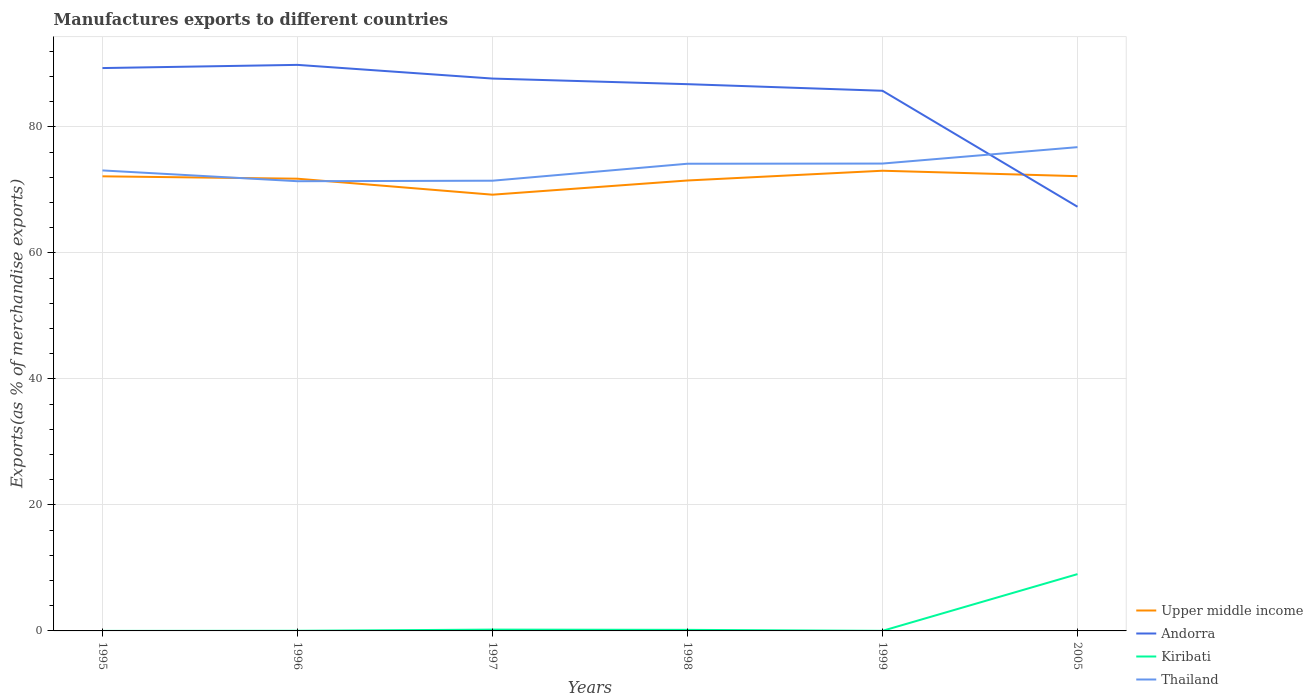Is the number of lines equal to the number of legend labels?
Your response must be concise. Yes. Across all years, what is the maximum percentage of exports to different countries in Thailand?
Keep it short and to the point. 71.39. In which year was the percentage of exports to different countries in Andorra maximum?
Your answer should be very brief. 2005. What is the total percentage of exports to different countries in Upper middle income in the graph?
Keep it short and to the point. -2.94. What is the difference between the highest and the second highest percentage of exports to different countries in Andorra?
Give a very brief answer. 22.52. How many lines are there?
Give a very brief answer. 4. What is the difference between two consecutive major ticks on the Y-axis?
Ensure brevity in your answer.  20. Are the values on the major ticks of Y-axis written in scientific E-notation?
Your response must be concise. No. Where does the legend appear in the graph?
Make the answer very short. Bottom right. How many legend labels are there?
Provide a succinct answer. 4. What is the title of the graph?
Offer a very short reply. Manufactures exports to different countries. Does "St. Lucia" appear as one of the legend labels in the graph?
Ensure brevity in your answer.  No. What is the label or title of the Y-axis?
Provide a short and direct response. Exports(as % of merchandise exports). What is the Exports(as % of merchandise exports) of Upper middle income in 1995?
Give a very brief answer. 72.16. What is the Exports(as % of merchandise exports) in Andorra in 1995?
Your answer should be very brief. 89.35. What is the Exports(as % of merchandise exports) of Kiribati in 1995?
Your answer should be compact. 0. What is the Exports(as % of merchandise exports) of Thailand in 1995?
Make the answer very short. 73.1. What is the Exports(as % of merchandise exports) in Upper middle income in 1996?
Provide a short and direct response. 71.79. What is the Exports(as % of merchandise exports) of Andorra in 1996?
Make the answer very short. 89.86. What is the Exports(as % of merchandise exports) in Kiribati in 1996?
Provide a succinct answer. 0.02. What is the Exports(as % of merchandise exports) in Thailand in 1996?
Make the answer very short. 71.39. What is the Exports(as % of merchandise exports) of Upper middle income in 1997?
Your answer should be very brief. 69.25. What is the Exports(as % of merchandise exports) in Andorra in 1997?
Ensure brevity in your answer.  87.68. What is the Exports(as % of merchandise exports) in Kiribati in 1997?
Give a very brief answer. 0.21. What is the Exports(as % of merchandise exports) of Thailand in 1997?
Provide a succinct answer. 71.47. What is the Exports(as % of merchandise exports) of Upper middle income in 1998?
Offer a terse response. 71.5. What is the Exports(as % of merchandise exports) in Andorra in 1998?
Keep it short and to the point. 86.79. What is the Exports(as % of merchandise exports) in Kiribati in 1998?
Your answer should be compact. 0.17. What is the Exports(as % of merchandise exports) in Thailand in 1998?
Keep it short and to the point. 74.16. What is the Exports(as % of merchandise exports) of Upper middle income in 1999?
Provide a succinct answer. 73.05. What is the Exports(as % of merchandise exports) of Andorra in 1999?
Give a very brief answer. 85.75. What is the Exports(as % of merchandise exports) of Kiribati in 1999?
Your answer should be very brief. 0.01. What is the Exports(as % of merchandise exports) of Thailand in 1999?
Your answer should be very brief. 74.19. What is the Exports(as % of merchandise exports) of Upper middle income in 2005?
Your answer should be compact. 72.19. What is the Exports(as % of merchandise exports) of Andorra in 2005?
Offer a terse response. 67.34. What is the Exports(as % of merchandise exports) of Kiribati in 2005?
Keep it short and to the point. 9.02. What is the Exports(as % of merchandise exports) of Thailand in 2005?
Offer a terse response. 76.8. Across all years, what is the maximum Exports(as % of merchandise exports) of Upper middle income?
Your answer should be very brief. 73.05. Across all years, what is the maximum Exports(as % of merchandise exports) of Andorra?
Your answer should be compact. 89.86. Across all years, what is the maximum Exports(as % of merchandise exports) of Kiribati?
Make the answer very short. 9.02. Across all years, what is the maximum Exports(as % of merchandise exports) of Thailand?
Provide a short and direct response. 76.8. Across all years, what is the minimum Exports(as % of merchandise exports) in Upper middle income?
Your response must be concise. 69.25. Across all years, what is the minimum Exports(as % of merchandise exports) in Andorra?
Your answer should be compact. 67.34. Across all years, what is the minimum Exports(as % of merchandise exports) of Kiribati?
Ensure brevity in your answer.  0. Across all years, what is the minimum Exports(as % of merchandise exports) of Thailand?
Provide a short and direct response. 71.39. What is the total Exports(as % of merchandise exports) in Upper middle income in the graph?
Offer a very short reply. 429.95. What is the total Exports(as % of merchandise exports) in Andorra in the graph?
Offer a very short reply. 506.76. What is the total Exports(as % of merchandise exports) in Kiribati in the graph?
Keep it short and to the point. 9.43. What is the total Exports(as % of merchandise exports) of Thailand in the graph?
Keep it short and to the point. 441.11. What is the difference between the Exports(as % of merchandise exports) of Upper middle income in 1995 and that in 1996?
Provide a short and direct response. 0.38. What is the difference between the Exports(as % of merchandise exports) in Andorra in 1995 and that in 1996?
Offer a terse response. -0.51. What is the difference between the Exports(as % of merchandise exports) in Kiribati in 1995 and that in 1996?
Offer a very short reply. -0.02. What is the difference between the Exports(as % of merchandise exports) in Thailand in 1995 and that in 1996?
Provide a succinct answer. 1.71. What is the difference between the Exports(as % of merchandise exports) in Upper middle income in 1995 and that in 1997?
Keep it short and to the point. 2.92. What is the difference between the Exports(as % of merchandise exports) of Andorra in 1995 and that in 1997?
Provide a short and direct response. 1.67. What is the difference between the Exports(as % of merchandise exports) in Kiribati in 1995 and that in 1997?
Keep it short and to the point. -0.21. What is the difference between the Exports(as % of merchandise exports) of Thailand in 1995 and that in 1997?
Provide a succinct answer. 1.63. What is the difference between the Exports(as % of merchandise exports) of Upper middle income in 1995 and that in 1998?
Make the answer very short. 0.66. What is the difference between the Exports(as % of merchandise exports) of Andorra in 1995 and that in 1998?
Give a very brief answer. 2.56. What is the difference between the Exports(as % of merchandise exports) in Kiribati in 1995 and that in 1998?
Make the answer very short. -0.17. What is the difference between the Exports(as % of merchandise exports) in Thailand in 1995 and that in 1998?
Keep it short and to the point. -1.06. What is the difference between the Exports(as % of merchandise exports) in Upper middle income in 1995 and that in 1999?
Make the answer very short. -0.89. What is the difference between the Exports(as % of merchandise exports) in Andorra in 1995 and that in 1999?
Give a very brief answer. 3.6. What is the difference between the Exports(as % of merchandise exports) in Kiribati in 1995 and that in 1999?
Provide a succinct answer. -0.01. What is the difference between the Exports(as % of merchandise exports) of Thailand in 1995 and that in 1999?
Give a very brief answer. -1.09. What is the difference between the Exports(as % of merchandise exports) of Upper middle income in 1995 and that in 2005?
Offer a very short reply. -0.03. What is the difference between the Exports(as % of merchandise exports) of Andorra in 1995 and that in 2005?
Give a very brief answer. 22.01. What is the difference between the Exports(as % of merchandise exports) of Kiribati in 1995 and that in 2005?
Offer a very short reply. -9.02. What is the difference between the Exports(as % of merchandise exports) of Thailand in 1995 and that in 2005?
Your answer should be compact. -3.7. What is the difference between the Exports(as % of merchandise exports) in Upper middle income in 1996 and that in 1997?
Your response must be concise. 2.54. What is the difference between the Exports(as % of merchandise exports) in Andorra in 1996 and that in 1997?
Your answer should be compact. 2.17. What is the difference between the Exports(as % of merchandise exports) in Kiribati in 1996 and that in 1997?
Your response must be concise. -0.19. What is the difference between the Exports(as % of merchandise exports) in Thailand in 1996 and that in 1997?
Your answer should be very brief. -0.08. What is the difference between the Exports(as % of merchandise exports) of Upper middle income in 1996 and that in 1998?
Give a very brief answer. 0.28. What is the difference between the Exports(as % of merchandise exports) in Andorra in 1996 and that in 1998?
Your response must be concise. 3.06. What is the difference between the Exports(as % of merchandise exports) in Kiribati in 1996 and that in 1998?
Provide a succinct answer. -0.15. What is the difference between the Exports(as % of merchandise exports) in Thailand in 1996 and that in 1998?
Ensure brevity in your answer.  -2.78. What is the difference between the Exports(as % of merchandise exports) of Upper middle income in 1996 and that in 1999?
Your answer should be very brief. -1.27. What is the difference between the Exports(as % of merchandise exports) of Andorra in 1996 and that in 1999?
Offer a terse response. 4.11. What is the difference between the Exports(as % of merchandise exports) of Kiribati in 1996 and that in 1999?
Keep it short and to the point. 0.01. What is the difference between the Exports(as % of merchandise exports) in Thailand in 1996 and that in 1999?
Make the answer very short. -2.8. What is the difference between the Exports(as % of merchandise exports) of Upper middle income in 1996 and that in 2005?
Provide a succinct answer. -0.41. What is the difference between the Exports(as % of merchandise exports) of Andorra in 1996 and that in 2005?
Ensure brevity in your answer.  22.52. What is the difference between the Exports(as % of merchandise exports) of Kiribati in 1996 and that in 2005?
Keep it short and to the point. -9. What is the difference between the Exports(as % of merchandise exports) of Thailand in 1996 and that in 2005?
Give a very brief answer. -5.41. What is the difference between the Exports(as % of merchandise exports) in Upper middle income in 1997 and that in 1998?
Your answer should be compact. -2.25. What is the difference between the Exports(as % of merchandise exports) of Andorra in 1997 and that in 1998?
Give a very brief answer. 0.89. What is the difference between the Exports(as % of merchandise exports) of Thailand in 1997 and that in 1998?
Offer a very short reply. -2.7. What is the difference between the Exports(as % of merchandise exports) in Upper middle income in 1997 and that in 1999?
Offer a terse response. -3.8. What is the difference between the Exports(as % of merchandise exports) in Andorra in 1997 and that in 1999?
Make the answer very short. 1.94. What is the difference between the Exports(as % of merchandise exports) of Kiribati in 1997 and that in 1999?
Provide a succinct answer. 0.2. What is the difference between the Exports(as % of merchandise exports) of Thailand in 1997 and that in 1999?
Offer a very short reply. -2.72. What is the difference between the Exports(as % of merchandise exports) of Upper middle income in 1997 and that in 2005?
Offer a terse response. -2.94. What is the difference between the Exports(as % of merchandise exports) of Andorra in 1997 and that in 2005?
Offer a very short reply. 20.35. What is the difference between the Exports(as % of merchandise exports) of Kiribati in 1997 and that in 2005?
Your answer should be very brief. -8.81. What is the difference between the Exports(as % of merchandise exports) of Thailand in 1997 and that in 2005?
Your answer should be very brief. -5.33. What is the difference between the Exports(as % of merchandise exports) of Upper middle income in 1998 and that in 1999?
Ensure brevity in your answer.  -1.55. What is the difference between the Exports(as % of merchandise exports) in Andorra in 1998 and that in 1999?
Your answer should be very brief. 1.04. What is the difference between the Exports(as % of merchandise exports) in Kiribati in 1998 and that in 1999?
Give a very brief answer. 0.16. What is the difference between the Exports(as % of merchandise exports) in Thailand in 1998 and that in 1999?
Offer a terse response. -0.03. What is the difference between the Exports(as % of merchandise exports) in Upper middle income in 1998 and that in 2005?
Provide a succinct answer. -0.69. What is the difference between the Exports(as % of merchandise exports) of Andorra in 1998 and that in 2005?
Your answer should be compact. 19.46. What is the difference between the Exports(as % of merchandise exports) in Kiribati in 1998 and that in 2005?
Make the answer very short. -8.85. What is the difference between the Exports(as % of merchandise exports) in Thailand in 1998 and that in 2005?
Your answer should be very brief. -2.63. What is the difference between the Exports(as % of merchandise exports) of Upper middle income in 1999 and that in 2005?
Keep it short and to the point. 0.86. What is the difference between the Exports(as % of merchandise exports) of Andorra in 1999 and that in 2005?
Provide a short and direct response. 18.41. What is the difference between the Exports(as % of merchandise exports) of Kiribati in 1999 and that in 2005?
Provide a short and direct response. -9. What is the difference between the Exports(as % of merchandise exports) in Thailand in 1999 and that in 2005?
Provide a short and direct response. -2.6. What is the difference between the Exports(as % of merchandise exports) of Upper middle income in 1995 and the Exports(as % of merchandise exports) of Andorra in 1996?
Make the answer very short. -17.69. What is the difference between the Exports(as % of merchandise exports) in Upper middle income in 1995 and the Exports(as % of merchandise exports) in Kiribati in 1996?
Provide a succinct answer. 72.14. What is the difference between the Exports(as % of merchandise exports) of Upper middle income in 1995 and the Exports(as % of merchandise exports) of Thailand in 1996?
Ensure brevity in your answer.  0.78. What is the difference between the Exports(as % of merchandise exports) in Andorra in 1995 and the Exports(as % of merchandise exports) in Kiribati in 1996?
Offer a very short reply. 89.33. What is the difference between the Exports(as % of merchandise exports) of Andorra in 1995 and the Exports(as % of merchandise exports) of Thailand in 1996?
Make the answer very short. 17.96. What is the difference between the Exports(as % of merchandise exports) in Kiribati in 1995 and the Exports(as % of merchandise exports) in Thailand in 1996?
Provide a succinct answer. -71.39. What is the difference between the Exports(as % of merchandise exports) of Upper middle income in 1995 and the Exports(as % of merchandise exports) of Andorra in 1997?
Make the answer very short. -15.52. What is the difference between the Exports(as % of merchandise exports) in Upper middle income in 1995 and the Exports(as % of merchandise exports) in Kiribati in 1997?
Make the answer very short. 71.96. What is the difference between the Exports(as % of merchandise exports) of Upper middle income in 1995 and the Exports(as % of merchandise exports) of Thailand in 1997?
Your response must be concise. 0.7. What is the difference between the Exports(as % of merchandise exports) in Andorra in 1995 and the Exports(as % of merchandise exports) in Kiribati in 1997?
Your answer should be very brief. 89.14. What is the difference between the Exports(as % of merchandise exports) of Andorra in 1995 and the Exports(as % of merchandise exports) of Thailand in 1997?
Give a very brief answer. 17.88. What is the difference between the Exports(as % of merchandise exports) of Kiribati in 1995 and the Exports(as % of merchandise exports) of Thailand in 1997?
Give a very brief answer. -71.47. What is the difference between the Exports(as % of merchandise exports) in Upper middle income in 1995 and the Exports(as % of merchandise exports) in Andorra in 1998?
Offer a terse response. -14.63. What is the difference between the Exports(as % of merchandise exports) in Upper middle income in 1995 and the Exports(as % of merchandise exports) in Kiribati in 1998?
Offer a terse response. 72. What is the difference between the Exports(as % of merchandise exports) in Upper middle income in 1995 and the Exports(as % of merchandise exports) in Thailand in 1998?
Your answer should be compact. -2. What is the difference between the Exports(as % of merchandise exports) in Andorra in 1995 and the Exports(as % of merchandise exports) in Kiribati in 1998?
Make the answer very short. 89.18. What is the difference between the Exports(as % of merchandise exports) in Andorra in 1995 and the Exports(as % of merchandise exports) in Thailand in 1998?
Offer a terse response. 15.19. What is the difference between the Exports(as % of merchandise exports) of Kiribati in 1995 and the Exports(as % of merchandise exports) of Thailand in 1998?
Offer a very short reply. -74.16. What is the difference between the Exports(as % of merchandise exports) in Upper middle income in 1995 and the Exports(as % of merchandise exports) in Andorra in 1999?
Make the answer very short. -13.58. What is the difference between the Exports(as % of merchandise exports) of Upper middle income in 1995 and the Exports(as % of merchandise exports) of Kiribati in 1999?
Your answer should be very brief. 72.15. What is the difference between the Exports(as % of merchandise exports) in Upper middle income in 1995 and the Exports(as % of merchandise exports) in Thailand in 1999?
Offer a terse response. -2.03. What is the difference between the Exports(as % of merchandise exports) of Andorra in 1995 and the Exports(as % of merchandise exports) of Kiribati in 1999?
Make the answer very short. 89.34. What is the difference between the Exports(as % of merchandise exports) of Andorra in 1995 and the Exports(as % of merchandise exports) of Thailand in 1999?
Provide a succinct answer. 15.16. What is the difference between the Exports(as % of merchandise exports) of Kiribati in 1995 and the Exports(as % of merchandise exports) of Thailand in 1999?
Offer a terse response. -74.19. What is the difference between the Exports(as % of merchandise exports) in Upper middle income in 1995 and the Exports(as % of merchandise exports) in Andorra in 2005?
Make the answer very short. 4.83. What is the difference between the Exports(as % of merchandise exports) of Upper middle income in 1995 and the Exports(as % of merchandise exports) of Kiribati in 2005?
Your answer should be compact. 63.15. What is the difference between the Exports(as % of merchandise exports) in Upper middle income in 1995 and the Exports(as % of merchandise exports) in Thailand in 2005?
Offer a very short reply. -4.63. What is the difference between the Exports(as % of merchandise exports) in Andorra in 1995 and the Exports(as % of merchandise exports) in Kiribati in 2005?
Offer a terse response. 80.33. What is the difference between the Exports(as % of merchandise exports) in Andorra in 1995 and the Exports(as % of merchandise exports) in Thailand in 2005?
Offer a terse response. 12.55. What is the difference between the Exports(as % of merchandise exports) of Kiribati in 1995 and the Exports(as % of merchandise exports) of Thailand in 2005?
Keep it short and to the point. -76.79. What is the difference between the Exports(as % of merchandise exports) in Upper middle income in 1996 and the Exports(as % of merchandise exports) in Andorra in 1997?
Give a very brief answer. -15.9. What is the difference between the Exports(as % of merchandise exports) of Upper middle income in 1996 and the Exports(as % of merchandise exports) of Kiribati in 1997?
Give a very brief answer. 71.58. What is the difference between the Exports(as % of merchandise exports) of Upper middle income in 1996 and the Exports(as % of merchandise exports) of Thailand in 1997?
Your response must be concise. 0.32. What is the difference between the Exports(as % of merchandise exports) in Andorra in 1996 and the Exports(as % of merchandise exports) in Kiribati in 1997?
Offer a terse response. 89.65. What is the difference between the Exports(as % of merchandise exports) of Andorra in 1996 and the Exports(as % of merchandise exports) of Thailand in 1997?
Your answer should be very brief. 18.39. What is the difference between the Exports(as % of merchandise exports) of Kiribati in 1996 and the Exports(as % of merchandise exports) of Thailand in 1997?
Offer a very short reply. -71.45. What is the difference between the Exports(as % of merchandise exports) of Upper middle income in 1996 and the Exports(as % of merchandise exports) of Andorra in 1998?
Your response must be concise. -15.01. What is the difference between the Exports(as % of merchandise exports) of Upper middle income in 1996 and the Exports(as % of merchandise exports) of Kiribati in 1998?
Provide a short and direct response. 71.62. What is the difference between the Exports(as % of merchandise exports) in Upper middle income in 1996 and the Exports(as % of merchandise exports) in Thailand in 1998?
Your answer should be compact. -2.38. What is the difference between the Exports(as % of merchandise exports) in Andorra in 1996 and the Exports(as % of merchandise exports) in Kiribati in 1998?
Ensure brevity in your answer.  89.69. What is the difference between the Exports(as % of merchandise exports) of Andorra in 1996 and the Exports(as % of merchandise exports) of Thailand in 1998?
Offer a very short reply. 15.69. What is the difference between the Exports(as % of merchandise exports) in Kiribati in 1996 and the Exports(as % of merchandise exports) in Thailand in 1998?
Your response must be concise. -74.14. What is the difference between the Exports(as % of merchandise exports) in Upper middle income in 1996 and the Exports(as % of merchandise exports) in Andorra in 1999?
Ensure brevity in your answer.  -13.96. What is the difference between the Exports(as % of merchandise exports) in Upper middle income in 1996 and the Exports(as % of merchandise exports) in Kiribati in 1999?
Your answer should be very brief. 71.77. What is the difference between the Exports(as % of merchandise exports) of Upper middle income in 1996 and the Exports(as % of merchandise exports) of Thailand in 1999?
Make the answer very short. -2.41. What is the difference between the Exports(as % of merchandise exports) of Andorra in 1996 and the Exports(as % of merchandise exports) of Kiribati in 1999?
Offer a terse response. 89.84. What is the difference between the Exports(as % of merchandise exports) in Andorra in 1996 and the Exports(as % of merchandise exports) in Thailand in 1999?
Your response must be concise. 15.66. What is the difference between the Exports(as % of merchandise exports) of Kiribati in 1996 and the Exports(as % of merchandise exports) of Thailand in 1999?
Give a very brief answer. -74.17. What is the difference between the Exports(as % of merchandise exports) in Upper middle income in 1996 and the Exports(as % of merchandise exports) in Andorra in 2005?
Your answer should be compact. 4.45. What is the difference between the Exports(as % of merchandise exports) in Upper middle income in 1996 and the Exports(as % of merchandise exports) in Kiribati in 2005?
Ensure brevity in your answer.  62.77. What is the difference between the Exports(as % of merchandise exports) in Upper middle income in 1996 and the Exports(as % of merchandise exports) in Thailand in 2005?
Your response must be concise. -5.01. What is the difference between the Exports(as % of merchandise exports) of Andorra in 1996 and the Exports(as % of merchandise exports) of Kiribati in 2005?
Provide a succinct answer. 80.84. What is the difference between the Exports(as % of merchandise exports) of Andorra in 1996 and the Exports(as % of merchandise exports) of Thailand in 2005?
Ensure brevity in your answer.  13.06. What is the difference between the Exports(as % of merchandise exports) in Kiribati in 1996 and the Exports(as % of merchandise exports) in Thailand in 2005?
Your answer should be very brief. -76.77. What is the difference between the Exports(as % of merchandise exports) of Upper middle income in 1997 and the Exports(as % of merchandise exports) of Andorra in 1998?
Your answer should be very brief. -17.54. What is the difference between the Exports(as % of merchandise exports) of Upper middle income in 1997 and the Exports(as % of merchandise exports) of Kiribati in 1998?
Provide a succinct answer. 69.08. What is the difference between the Exports(as % of merchandise exports) in Upper middle income in 1997 and the Exports(as % of merchandise exports) in Thailand in 1998?
Offer a terse response. -4.91. What is the difference between the Exports(as % of merchandise exports) in Andorra in 1997 and the Exports(as % of merchandise exports) in Kiribati in 1998?
Provide a succinct answer. 87.51. What is the difference between the Exports(as % of merchandise exports) in Andorra in 1997 and the Exports(as % of merchandise exports) in Thailand in 1998?
Offer a terse response. 13.52. What is the difference between the Exports(as % of merchandise exports) of Kiribati in 1997 and the Exports(as % of merchandise exports) of Thailand in 1998?
Offer a very short reply. -73.95. What is the difference between the Exports(as % of merchandise exports) of Upper middle income in 1997 and the Exports(as % of merchandise exports) of Andorra in 1999?
Offer a terse response. -16.5. What is the difference between the Exports(as % of merchandise exports) in Upper middle income in 1997 and the Exports(as % of merchandise exports) in Kiribati in 1999?
Keep it short and to the point. 69.24. What is the difference between the Exports(as % of merchandise exports) in Upper middle income in 1997 and the Exports(as % of merchandise exports) in Thailand in 1999?
Your answer should be very brief. -4.94. What is the difference between the Exports(as % of merchandise exports) in Andorra in 1997 and the Exports(as % of merchandise exports) in Kiribati in 1999?
Your answer should be compact. 87.67. What is the difference between the Exports(as % of merchandise exports) in Andorra in 1997 and the Exports(as % of merchandise exports) in Thailand in 1999?
Make the answer very short. 13.49. What is the difference between the Exports(as % of merchandise exports) of Kiribati in 1997 and the Exports(as % of merchandise exports) of Thailand in 1999?
Give a very brief answer. -73.98. What is the difference between the Exports(as % of merchandise exports) in Upper middle income in 1997 and the Exports(as % of merchandise exports) in Andorra in 2005?
Ensure brevity in your answer.  1.91. What is the difference between the Exports(as % of merchandise exports) in Upper middle income in 1997 and the Exports(as % of merchandise exports) in Kiribati in 2005?
Keep it short and to the point. 60.23. What is the difference between the Exports(as % of merchandise exports) in Upper middle income in 1997 and the Exports(as % of merchandise exports) in Thailand in 2005?
Ensure brevity in your answer.  -7.55. What is the difference between the Exports(as % of merchandise exports) of Andorra in 1997 and the Exports(as % of merchandise exports) of Kiribati in 2005?
Make the answer very short. 78.67. What is the difference between the Exports(as % of merchandise exports) in Andorra in 1997 and the Exports(as % of merchandise exports) in Thailand in 2005?
Ensure brevity in your answer.  10.89. What is the difference between the Exports(as % of merchandise exports) of Kiribati in 1997 and the Exports(as % of merchandise exports) of Thailand in 2005?
Your answer should be compact. -76.59. What is the difference between the Exports(as % of merchandise exports) in Upper middle income in 1998 and the Exports(as % of merchandise exports) in Andorra in 1999?
Make the answer very short. -14.24. What is the difference between the Exports(as % of merchandise exports) of Upper middle income in 1998 and the Exports(as % of merchandise exports) of Kiribati in 1999?
Provide a short and direct response. 71.49. What is the difference between the Exports(as % of merchandise exports) in Upper middle income in 1998 and the Exports(as % of merchandise exports) in Thailand in 1999?
Keep it short and to the point. -2.69. What is the difference between the Exports(as % of merchandise exports) in Andorra in 1998 and the Exports(as % of merchandise exports) in Kiribati in 1999?
Your answer should be very brief. 86.78. What is the difference between the Exports(as % of merchandise exports) of Andorra in 1998 and the Exports(as % of merchandise exports) of Thailand in 1999?
Make the answer very short. 12.6. What is the difference between the Exports(as % of merchandise exports) in Kiribati in 1998 and the Exports(as % of merchandise exports) in Thailand in 1999?
Ensure brevity in your answer.  -74.02. What is the difference between the Exports(as % of merchandise exports) of Upper middle income in 1998 and the Exports(as % of merchandise exports) of Andorra in 2005?
Ensure brevity in your answer.  4.17. What is the difference between the Exports(as % of merchandise exports) in Upper middle income in 1998 and the Exports(as % of merchandise exports) in Kiribati in 2005?
Keep it short and to the point. 62.49. What is the difference between the Exports(as % of merchandise exports) of Upper middle income in 1998 and the Exports(as % of merchandise exports) of Thailand in 2005?
Provide a short and direct response. -5.29. What is the difference between the Exports(as % of merchandise exports) of Andorra in 1998 and the Exports(as % of merchandise exports) of Kiribati in 2005?
Keep it short and to the point. 77.77. What is the difference between the Exports(as % of merchandise exports) of Andorra in 1998 and the Exports(as % of merchandise exports) of Thailand in 2005?
Your answer should be very brief. 10. What is the difference between the Exports(as % of merchandise exports) of Kiribati in 1998 and the Exports(as % of merchandise exports) of Thailand in 2005?
Offer a terse response. -76.63. What is the difference between the Exports(as % of merchandise exports) of Upper middle income in 1999 and the Exports(as % of merchandise exports) of Andorra in 2005?
Keep it short and to the point. 5.72. What is the difference between the Exports(as % of merchandise exports) of Upper middle income in 1999 and the Exports(as % of merchandise exports) of Kiribati in 2005?
Offer a very short reply. 64.04. What is the difference between the Exports(as % of merchandise exports) in Upper middle income in 1999 and the Exports(as % of merchandise exports) in Thailand in 2005?
Offer a terse response. -3.74. What is the difference between the Exports(as % of merchandise exports) of Andorra in 1999 and the Exports(as % of merchandise exports) of Kiribati in 2005?
Your answer should be very brief. 76.73. What is the difference between the Exports(as % of merchandise exports) in Andorra in 1999 and the Exports(as % of merchandise exports) in Thailand in 2005?
Provide a succinct answer. 8.95. What is the difference between the Exports(as % of merchandise exports) of Kiribati in 1999 and the Exports(as % of merchandise exports) of Thailand in 2005?
Make the answer very short. -76.78. What is the average Exports(as % of merchandise exports) in Upper middle income per year?
Offer a very short reply. 71.66. What is the average Exports(as % of merchandise exports) in Andorra per year?
Provide a succinct answer. 84.46. What is the average Exports(as % of merchandise exports) in Kiribati per year?
Your response must be concise. 1.57. What is the average Exports(as % of merchandise exports) of Thailand per year?
Provide a succinct answer. 73.52. In the year 1995, what is the difference between the Exports(as % of merchandise exports) in Upper middle income and Exports(as % of merchandise exports) in Andorra?
Ensure brevity in your answer.  -17.19. In the year 1995, what is the difference between the Exports(as % of merchandise exports) of Upper middle income and Exports(as % of merchandise exports) of Kiribati?
Keep it short and to the point. 72.16. In the year 1995, what is the difference between the Exports(as % of merchandise exports) in Upper middle income and Exports(as % of merchandise exports) in Thailand?
Give a very brief answer. -0.94. In the year 1995, what is the difference between the Exports(as % of merchandise exports) of Andorra and Exports(as % of merchandise exports) of Kiribati?
Your answer should be very brief. 89.35. In the year 1995, what is the difference between the Exports(as % of merchandise exports) in Andorra and Exports(as % of merchandise exports) in Thailand?
Offer a terse response. 16.25. In the year 1995, what is the difference between the Exports(as % of merchandise exports) of Kiribati and Exports(as % of merchandise exports) of Thailand?
Make the answer very short. -73.1. In the year 1996, what is the difference between the Exports(as % of merchandise exports) in Upper middle income and Exports(as % of merchandise exports) in Andorra?
Your response must be concise. -18.07. In the year 1996, what is the difference between the Exports(as % of merchandise exports) of Upper middle income and Exports(as % of merchandise exports) of Kiribati?
Offer a very short reply. 71.76. In the year 1996, what is the difference between the Exports(as % of merchandise exports) in Upper middle income and Exports(as % of merchandise exports) in Thailand?
Provide a short and direct response. 0.4. In the year 1996, what is the difference between the Exports(as % of merchandise exports) in Andorra and Exports(as % of merchandise exports) in Kiribati?
Ensure brevity in your answer.  89.83. In the year 1996, what is the difference between the Exports(as % of merchandise exports) of Andorra and Exports(as % of merchandise exports) of Thailand?
Provide a short and direct response. 18.47. In the year 1996, what is the difference between the Exports(as % of merchandise exports) of Kiribati and Exports(as % of merchandise exports) of Thailand?
Ensure brevity in your answer.  -71.37. In the year 1997, what is the difference between the Exports(as % of merchandise exports) in Upper middle income and Exports(as % of merchandise exports) in Andorra?
Your answer should be very brief. -18.43. In the year 1997, what is the difference between the Exports(as % of merchandise exports) of Upper middle income and Exports(as % of merchandise exports) of Kiribati?
Ensure brevity in your answer.  69.04. In the year 1997, what is the difference between the Exports(as % of merchandise exports) in Upper middle income and Exports(as % of merchandise exports) in Thailand?
Give a very brief answer. -2.22. In the year 1997, what is the difference between the Exports(as % of merchandise exports) in Andorra and Exports(as % of merchandise exports) in Kiribati?
Provide a short and direct response. 87.47. In the year 1997, what is the difference between the Exports(as % of merchandise exports) of Andorra and Exports(as % of merchandise exports) of Thailand?
Keep it short and to the point. 16.22. In the year 1997, what is the difference between the Exports(as % of merchandise exports) in Kiribati and Exports(as % of merchandise exports) in Thailand?
Provide a succinct answer. -71.26. In the year 1998, what is the difference between the Exports(as % of merchandise exports) in Upper middle income and Exports(as % of merchandise exports) in Andorra?
Your answer should be compact. -15.29. In the year 1998, what is the difference between the Exports(as % of merchandise exports) in Upper middle income and Exports(as % of merchandise exports) in Kiribati?
Give a very brief answer. 71.33. In the year 1998, what is the difference between the Exports(as % of merchandise exports) of Upper middle income and Exports(as % of merchandise exports) of Thailand?
Provide a short and direct response. -2.66. In the year 1998, what is the difference between the Exports(as % of merchandise exports) of Andorra and Exports(as % of merchandise exports) of Kiribati?
Offer a terse response. 86.62. In the year 1998, what is the difference between the Exports(as % of merchandise exports) in Andorra and Exports(as % of merchandise exports) in Thailand?
Provide a succinct answer. 12.63. In the year 1998, what is the difference between the Exports(as % of merchandise exports) of Kiribati and Exports(as % of merchandise exports) of Thailand?
Your answer should be compact. -73.99. In the year 1999, what is the difference between the Exports(as % of merchandise exports) of Upper middle income and Exports(as % of merchandise exports) of Andorra?
Your answer should be compact. -12.7. In the year 1999, what is the difference between the Exports(as % of merchandise exports) in Upper middle income and Exports(as % of merchandise exports) in Kiribati?
Your answer should be very brief. 73.04. In the year 1999, what is the difference between the Exports(as % of merchandise exports) of Upper middle income and Exports(as % of merchandise exports) of Thailand?
Provide a short and direct response. -1.14. In the year 1999, what is the difference between the Exports(as % of merchandise exports) in Andorra and Exports(as % of merchandise exports) in Kiribati?
Provide a succinct answer. 85.73. In the year 1999, what is the difference between the Exports(as % of merchandise exports) in Andorra and Exports(as % of merchandise exports) in Thailand?
Ensure brevity in your answer.  11.56. In the year 1999, what is the difference between the Exports(as % of merchandise exports) of Kiribati and Exports(as % of merchandise exports) of Thailand?
Offer a terse response. -74.18. In the year 2005, what is the difference between the Exports(as % of merchandise exports) of Upper middle income and Exports(as % of merchandise exports) of Andorra?
Your response must be concise. 4.86. In the year 2005, what is the difference between the Exports(as % of merchandise exports) of Upper middle income and Exports(as % of merchandise exports) of Kiribati?
Keep it short and to the point. 63.17. In the year 2005, what is the difference between the Exports(as % of merchandise exports) in Upper middle income and Exports(as % of merchandise exports) in Thailand?
Make the answer very short. -4.61. In the year 2005, what is the difference between the Exports(as % of merchandise exports) in Andorra and Exports(as % of merchandise exports) in Kiribati?
Ensure brevity in your answer.  58.32. In the year 2005, what is the difference between the Exports(as % of merchandise exports) in Andorra and Exports(as % of merchandise exports) in Thailand?
Offer a very short reply. -9.46. In the year 2005, what is the difference between the Exports(as % of merchandise exports) in Kiribati and Exports(as % of merchandise exports) in Thailand?
Ensure brevity in your answer.  -67.78. What is the ratio of the Exports(as % of merchandise exports) of Upper middle income in 1995 to that in 1996?
Give a very brief answer. 1.01. What is the ratio of the Exports(as % of merchandise exports) of Andorra in 1995 to that in 1996?
Provide a succinct answer. 0.99. What is the ratio of the Exports(as % of merchandise exports) in Kiribati in 1995 to that in 1996?
Make the answer very short. 0.06. What is the ratio of the Exports(as % of merchandise exports) of Upper middle income in 1995 to that in 1997?
Your answer should be compact. 1.04. What is the ratio of the Exports(as % of merchandise exports) in Kiribati in 1995 to that in 1997?
Give a very brief answer. 0.01. What is the ratio of the Exports(as % of merchandise exports) in Thailand in 1995 to that in 1997?
Offer a very short reply. 1.02. What is the ratio of the Exports(as % of merchandise exports) of Upper middle income in 1995 to that in 1998?
Offer a very short reply. 1.01. What is the ratio of the Exports(as % of merchandise exports) in Andorra in 1995 to that in 1998?
Offer a very short reply. 1.03. What is the ratio of the Exports(as % of merchandise exports) in Kiribati in 1995 to that in 1998?
Keep it short and to the point. 0.01. What is the ratio of the Exports(as % of merchandise exports) of Thailand in 1995 to that in 1998?
Your answer should be very brief. 0.99. What is the ratio of the Exports(as % of merchandise exports) of Upper middle income in 1995 to that in 1999?
Ensure brevity in your answer.  0.99. What is the ratio of the Exports(as % of merchandise exports) of Andorra in 1995 to that in 1999?
Offer a terse response. 1.04. What is the ratio of the Exports(as % of merchandise exports) of Kiribati in 1995 to that in 1999?
Make the answer very short. 0.1. What is the ratio of the Exports(as % of merchandise exports) in Thailand in 1995 to that in 1999?
Your answer should be very brief. 0.99. What is the ratio of the Exports(as % of merchandise exports) of Andorra in 1995 to that in 2005?
Your response must be concise. 1.33. What is the ratio of the Exports(as % of merchandise exports) of Kiribati in 1995 to that in 2005?
Your answer should be very brief. 0. What is the ratio of the Exports(as % of merchandise exports) in Thailand in 1995 to that in 2005?
Your answer should be compact. 0.95. What is the ratio of the Exports(as % of merchandise exports) of Upper middle income in 1996 to that in 1997?
Provide a short and direct response. 1.04. What is the ratio of the Exports(as % of merchandise exports) of Andorra in 1996 to that in 1997?
Provide a short and direct response. 1.02. What is the ratio of the Exports(as % of merchandise exports) in Kiribati in 1996 to that in 1997?
Ensure brevity in your answer.  0.1. What is the ratio of the Exports(as % of merchandise exports) of Andorra in 1996 to that in 1998?
Provide a succinct answer. 1.04. What is the ratio of the Exports(as % of merchandise exports) in Kiribati in 1996 to that in 1998?
Provide a succinct answer. 0.13. What is the ratio of the Exports(as % of merchandise exports) of Thailand in 1996 to that in 1998?
Your answer should be compact. 0.96. What is the ratio of the Exports(as % of merchandise exports) in Upper middle income in 1996 to that in 1999?
Make the answer very short. 0.98. What is the ratio of the Exports(as % of merchandise exports) in Andorra in 1996 to that in 1999?
Provide a succinct answer. 1.05. What is the ratio of the Exports(as % of merchandise exports) in Kiribati in 1996 to that in 1999?
Your answer should be compact. 1.62. What is the ratio of the Exports(as % of merchandise exports) in Thailand in 1996 to that in 1999?
Ensure brevity in your answer.  0.96. What is the ratio of the Exports(as % of merchandise exports) of Upper middle income in 1996 to that in 2005?
Ensure brevity in your answer.  0.99. What is the ratio of the Exports(as % of merchandise exports) of Andorra in 1996 to that in 2005?
Offer a terse response. 1.33. What is the ratio of the Exports(as % of merchandise exports) in Kiribati in 1996 to that in 2005?
Ensure brevity in your answer.  0. What is the ratio of the Exports(as % of merchandise exports) of Thailand in 1996 to that in 2005?
Ensure brevity in your answer.  0.93. What is the ratio of the Exports(as % of merchandise exports) of Upper middle income in 1997 to that in 1998?
Keep it short and to the point. 0.97. What is the ratio of the Exports(as % of merchandise exports) in Andorra in 1997 to that in 1998?
Offer a terse response. 1.01. What is the ratio of the Exports(as % of merchandise exports) of Kiribati in 1997 to that in 1998?
Offer a very short reply. 1.24. What is the ratio of the Exports(as % of merchandise exports) of Thailand in 1997 to that in 1998?
Give a very brief answer. 0.96. What is the ratio of the Exports(as % of merchandise exports) of Upper middle income in 1997 to that in 1999?
Provide a short and direct response. 0.95. What is the ratio of the Exports(as % of merchandise exports) of Andorra in 1997 to that in 1999?
Offer a terse response. 1.02. What is the ratio of the Exports(as % of merchandise exports) of Kiribati in 1997 to that in 1999?
Your answer should be compact. 15.83. What is the ratio of the Exports(as % of merchandise exports) of Thailand in 1997 to that in 1999?
Provide a short and direct response. 0.96. What is the ratio of the Exports(as % of merchandise exports) of Upper middle income in 1997 to that in 2005?
Your answer should be compact. 0.96. What is the ratio of the Exports(as % of merchandise exports) in Andorra in 1997 to that in 2005?
Give a very brief answer. 1.3. What is the ratio of the Exports(as % of merchandise exports) of Kiribati in 1997 to that in 2005?
Provide a short and direct response. 0.02. What is the ratio of the Exports(as % of merchandise exports) in Thailand in 1997 to that in 2005?
Give a very brief answer. 0.93. What is the ratio of the Exports(as % of merchandise exports) of Upper middle income in 1998 to that in 1999?
Make the answer very short. 0.98. What is the ratio of the Exports(as % of merchandise exports) in Andorra in 1998 to that in 1999?
Your answer should be compact. 1.01. What is the ratio of the Exports(as % of merchandise exports) of Kiribati in 1998 to that in 1999?
Provide a short and direct response. 12.8. What is the ratio of the Exports(as % of merchandise exports) of Thailand in 1998 to that in 1999?
Make the answer very short. 1. What is the ratio of the Exports(as % of merchandise exports) in Upper middle income in 1998 to that in 2005?
Make the answer very short. 0.99. What is the ratio of the Exports(as % of merchandise exports) of Andorra in 1998 to that in 2005?
Provide a succinct answer. 1.29. What is the ratio of the Exports(as % of merchandise exports) of Kiribati in 1998 to that in 2005?
Your answer should be very brief. 0.02. What is the ratio of the Exports(as % of merchandise exports) in Thailand in 1998 to that in 2005?
Give a very brief answer. 0.97. What is the ratio of the Exports(as % of merchandise exports) in Upper middle income in 1999 to that in 2005?
Your answer should be compact. 1.01. What is the ratio of the Exports(as % of merchandise exports) in Andorra in 1999 to that in 2005?
Offer a very short reply. 1.27. What is the ratio of the Exports(as % of merchandise exports) of Kiribati in 1999 to that in 2005?
Offer a very short reply. 0. What is the ratio of the Exports(as % of merchandise exports) in Thailand in 1999 to that in 2005?
Your response must be concise. 0.97. What is the difference between the highest and the second highest Exports(as % of merchandise exports) of Upper middle income?
Keep it short and to the point. 0.86. What is the difference between the highest and the second highest Exports(as % of merchandise exports) of Andorra?
Provide a short and direct response. 0.51. What is the difference between the highest and the second highest Exports(as % of merchandise exports) in Kiribati?
Make the answer very short. 8.81. What is the difference between the highest and the second highest Exports(as % of merchandise exports) of Thailand?
Offer a very short reply. 2.6. What is the difference between the highest and the lowest Exports(as % of merchandise exports) of Upper middle income?
Offer a terse response. 3.8. What is the difference between the highest and the lowest Exports(as % of merchandise exports) in Andorra?
Ensure brevity in your answer.  22.52. What is the difference between the highest and the lowest Exports(as % of merchandise exports) of Kiribati?
Offer a very short reply. 9.02. What is the difference between the highest and the lowest Exports(as % of merchandise exports) of Thailand?
Keep it short and to the point. 5.41. 